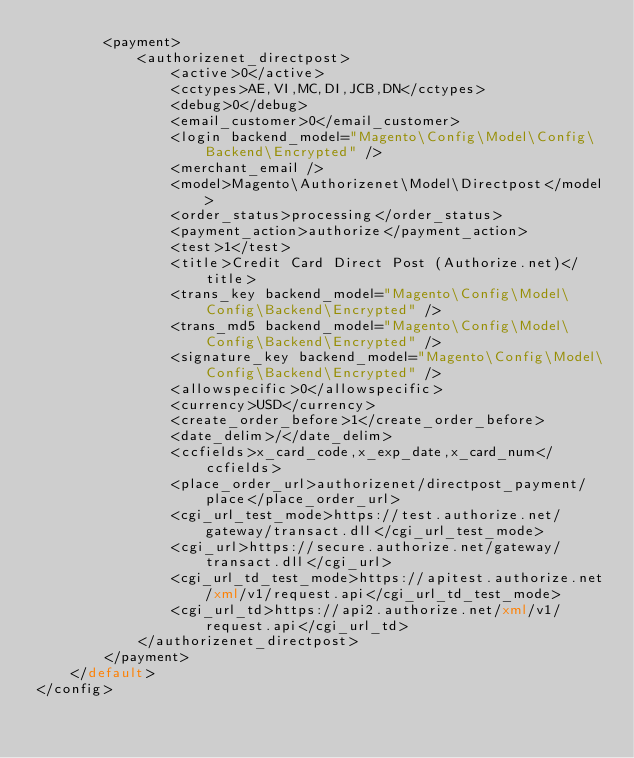Convert code to text. <code><loc_0><loc_0><loc_500><loc_500><_XML_>        <payment>
            <authorizenet_directpost>
                <active>0</active>
                <cctypes>AE,VI,MC,DI,JCB,DN</cctypes>
                <debug>0</debug>
                <email_customer>0</email_customer>
                <login backend_model="Magento\Config\Model\Config\Backend\Encrypted" />
                <merchant_email />
                <model>Magento\Authorizenet\Model\Directpost</model>
                <order_status>processing</order_status>
                <payment_action>authorize</payment_action>
                <test>1</test>
                <title>Credit Card Direct Post (Authorize.net)</title>
                <trans_key backend_model="Magento\Config\Model\Config\Backend\Encrypted" />
                <trans_md5 backend_model="Magento\Config\Model\Config\Backend\Encrypted" />
                <signature_key backend_model="Magento\Config\Model\Config\Backend\Encrypted" />
                <allowspecific>0</allowspecific>
                <currency>USD</currency>
                <create_order_before>1</create_order_before>
                <date_delim>/</date_delim>
                <ccfields>x_card_code,x_exp_date,x_card_num</ccfields>
                <place_order_url>authorizenet/directpost_payment/place</place_order_url>
                <cgi_url_test_mode>https://test.authorize.net/gateway/transact.dll</cgi_url_test_mode>
                <cgi_url>https://secure.authorize.net/gateway/transact.dll</cgi_url>
                <cgi_url_td_test_mode>https://apitest.authorize.net/xml/v1/request.api</cgi_url_td_test_mode>
                <cgi_url_td>https://api2.authorize.net/xml/v1/request.api</cgi_url_td>
            </authorizenet_directpost>
        </payment>
    </default>
</config>
</code> 